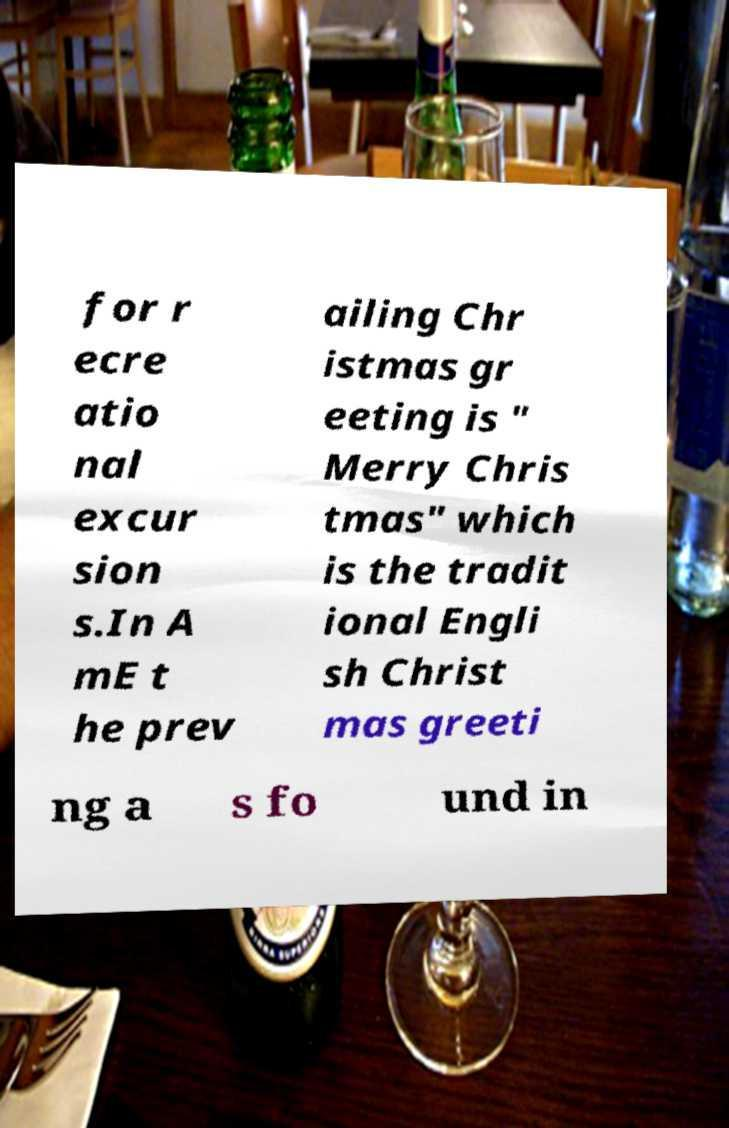Can you accurately transcribe the text from the provided image for me? for r ecre atio nal excur sion s.In A mE t he prev ailing Chr istmas gr eeting is " Merry Chris tmas" which is the tradit ional Engli sh Christ mas greeti ng a s fo und in 